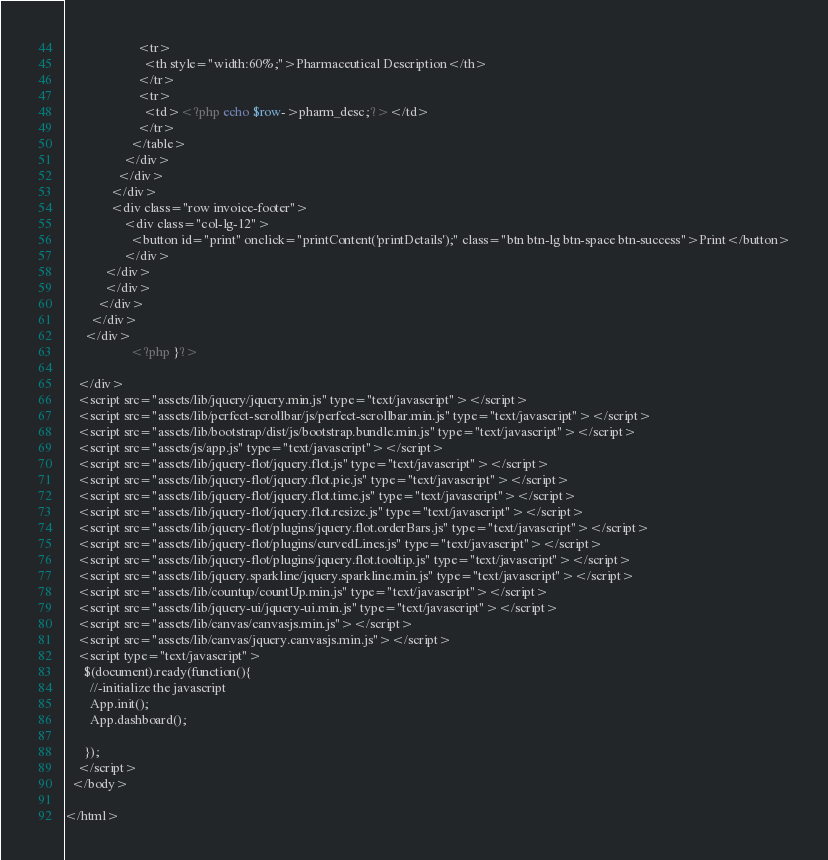<code> <loc_0><loc_0><loc_500><loc_500><_PHP_>                      <tr>
                        <th style="width:60%;">Pharmaceutical Description</th>
                      </tr>
                      <tr>
                        <td><?php echo $row->pharm_desc;?></td>
                      </tr>
                    </table>
                  </div>
                </div>
              </div>
              <div class="row invoice-footer">
                  <div class="col-lg-12">
                    <button id="print" onclick="printContent('printDetails');" class="btn btn-lg btn-space btn-success">Print</button>
                  </div>
            </div>
            </div>
          </div>          
        </div>
      </div>
                    <?php }?>
      
    </div>
    <script src="assets/lib/jquery/jquery.min.js" type="text/javascript"></script>
    <script src="assets/lib/perfect-scrollbar/js/perfect-scrollbar.min.js" type="text/javascript"></script>
    <script src="assets/lib/bootstrap/dist/js/bootstrap.bundle.min.js" type="text/javascript"></script>
    <script src="assets/js/app.js" type="text/javascript"></script>
    <script src="assets/lib/jquery-flot/jquery.flot.js" type="text/javascript"></script>
    <script src="assets/lib/jquery-flot/jquery.flot.pie.js" type="text/javascript"></script>
    <script src="assets/lib/jquery-flot/jquery.flot.time.js" type="text/javascript"></script>
    <script src="assets/lib/jquery-flot/jquery.flot.resize.js" type="text/javascript"></script>
    <script src="assets/lib/jquery-flot/plugins/jquery.flot.orderBars.js" type="text/javascript"></script>
    <script src="assets/lib/jquery-flot/plugins/curvedLines.js" type="text/javascript"></script>
    <script src="assets/lib/jquery-flot/plugins/jquery.flot.tooltip.js" type="text/javascript"></script>
    <script src="assets/lib/jquery.sparkline/jquery.sparkline.min.js" type="text/javascript"></script>
    <script src="assets/lib/countup/countUp.min.js" type="text/javascript"></script>
    <script src="assets/lib/jquery-ui/jquery-ui.min.js" type="text/javascript"></script>
    <script src="assets/lib/canvas/canvasjs.min.js"></script>
    <script src="assets/lib/canvas/jquery.canvasjs.min.js"></script>
    <script type="text/javascript">
      $(document).ready(function(){
      	//-initialize the javascript
      	App.init();
      	App.dashboard();
      
      });
    </script>
  </body>

</html></code> 